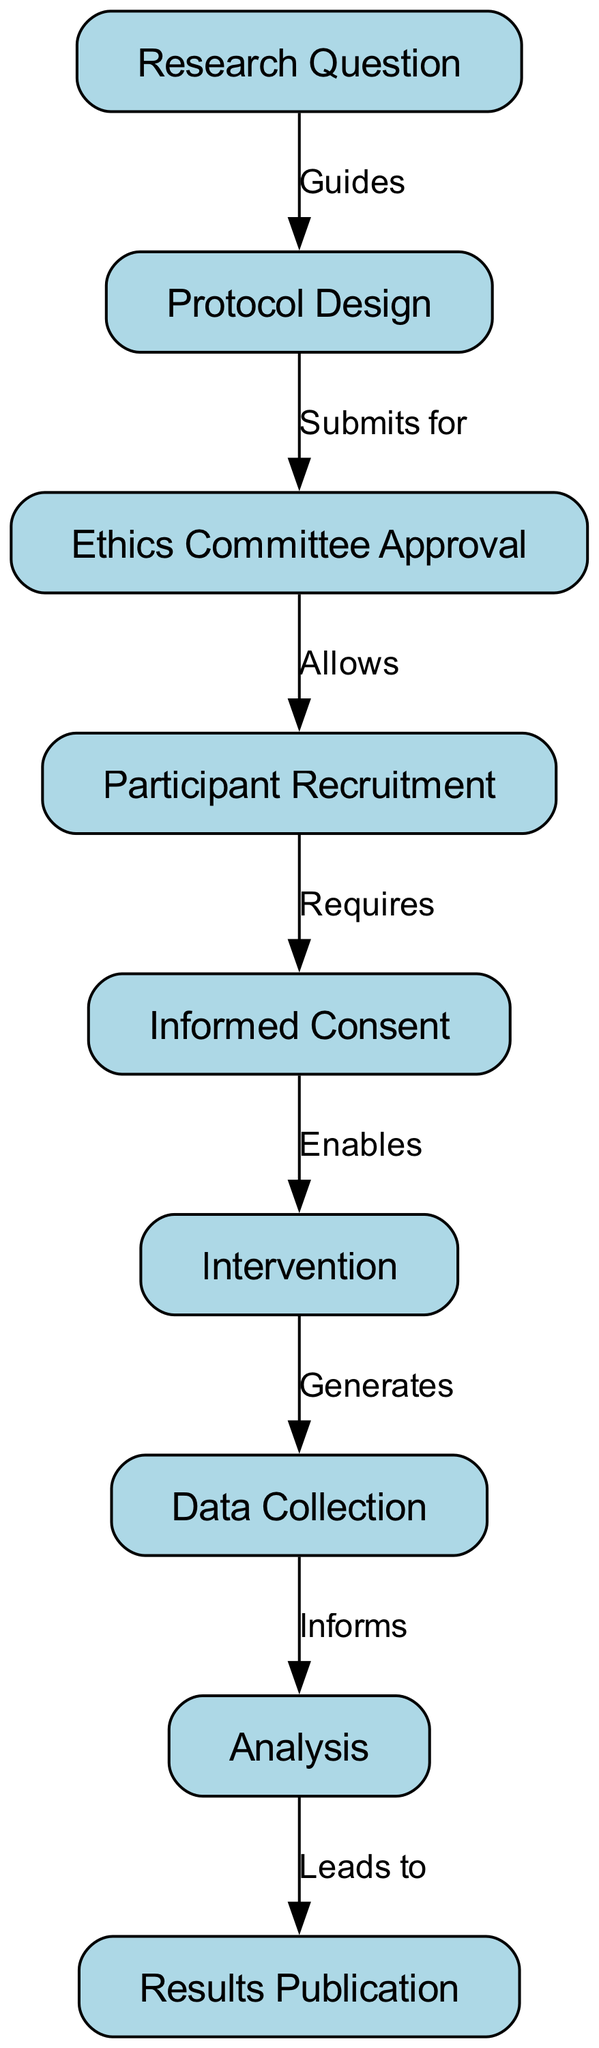What is the first step in the clinical trial process? The diagram starts with the "Research Question" node, indicating that formulating a research question initiates the clinical trial process.
Answer: Research Question How many nodes are there in the diagram? By counting all the unique components in the diagram, we see there are nine nodes representing different steps in the clinical trial process.
Answer: Nine What does "Protocol Design" submit for? The edge from the "Protocol Design" node to the "Ethics Committee Approval" node indicates that protocol design is submitted for ethics committee approval.
Answer: Ethics Committee Approval Which step requires participant recruitment? The edge from the "Participant Recruitment" node to the "Informed Consent" node indicates that informed consent requires participant recruitment as a preceding step.
Answer: Participant Recruitment What does the "Intervention" generate? The connection from the "Intervention" node to the "Data Collection" node shows that the intervention generates data collection as the next step.
Answer: Data Collection What is the relationship between "Analysis" and "Results Publication"? The edge from "Analysis" to "Results Publication" indicates that analysis leads to the publication of the results, reflecting a flow of information.
Answer: Leads to What enables informed consent? The relationship illustrated by the edge from "Informed Consent" to "Intervention" shows that informed consent enables the implementation of the intervention.
Answer: Enables How many edges are present in the diagram? By counting all the directional connections between the nodes, we find that there are eight edges representing the relationships between the steps.
Answer: Eight Which node allows participant recruitment? The edge from "Ethics Committee Approval" to "Participant Recruitment" indicates that ethics committee approval allows participant recruitment to proceed.
Answer: Allows What comes directly after data collection in this process? Following the flow in the diagram, data collection informs the analysis, which is the step that follows data collection.
Answer: Analysis 